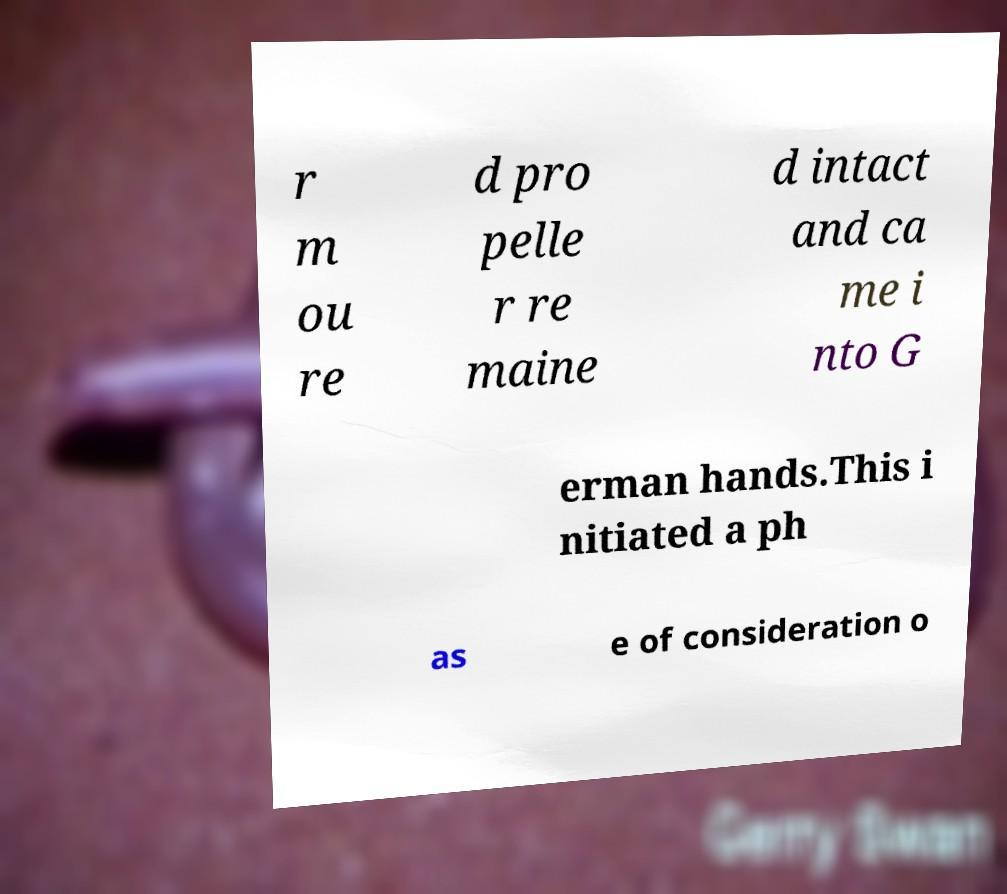Could you assist in decoding the text presented in this image and type it out clearly? r m ou re d pro pelle r re maine d intact and ca me i nto G erman hands.This i nitiated a ph as e of consideration o 